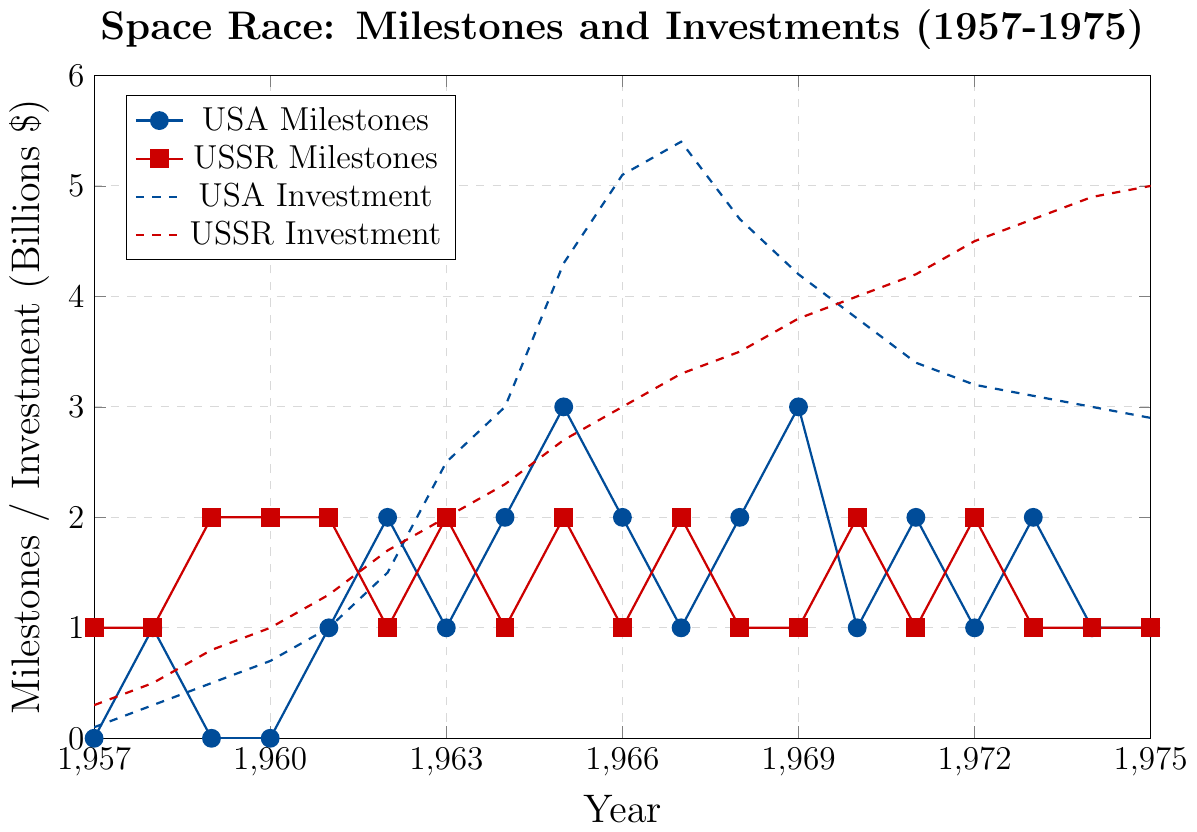When did the USA reach its peak investment in the space race? The USA's investment peaked when the dashed line for USA investment is at its highest point. This occurs around the year 1967.
Answer: 1967 Which country had more milestones in 1965? By looking at the markers for 1965, the USA milestones (marked by circles in blue) show a higher peak compared to the USSR milestones (marked by squares in red).
Answer: USA During which year did the USSR make the highest investment? Observing the dashed red line (USSR investment), we see the highest point is reached at the year 1975.
Answer: 1975 Compare the number of milestones achieved by the USA and USSR in 1964. Which country achieved more milestones that year? In 1964, the marker for USA milestones (circles in blue) is at a higher value (2) compared to the markers for USSR milestones (squares in red) which is at 1.
Answer: USA What was the investment difference between the USA and the USSR in 1968? In 1968, the USA's investment was at 4.7 billion, while the USSR's investment was at 3.5 billion. The difference is 4.7 - 3.5 = 1.2 billion dollars.
Answer: 1.2 billion dollars By how much did the USA increase its investment from 1960 to 1965? The USA's investment in 1960 was 0.7 billion, and in 1965 it was 4.3 billion. The increase is 4.3 - 0.7 = 3.6 billion dollars.
Answer: 3.6 billion dollars Which country showed more consistent growth in their investment over the years, as observed from the dashed lines? Observing the dashed lines, the USSR's investment shows a consistent upward trend without a sharp decline, whereas the USA's investment peaks in 1967 then declines.
Answer: USSR In what year did the USA have twice as many milestones as the USSR? In 1962, the USA had 2 milestones while the USSR had 1 milestone, making it twice as many.
Answer: 1962 